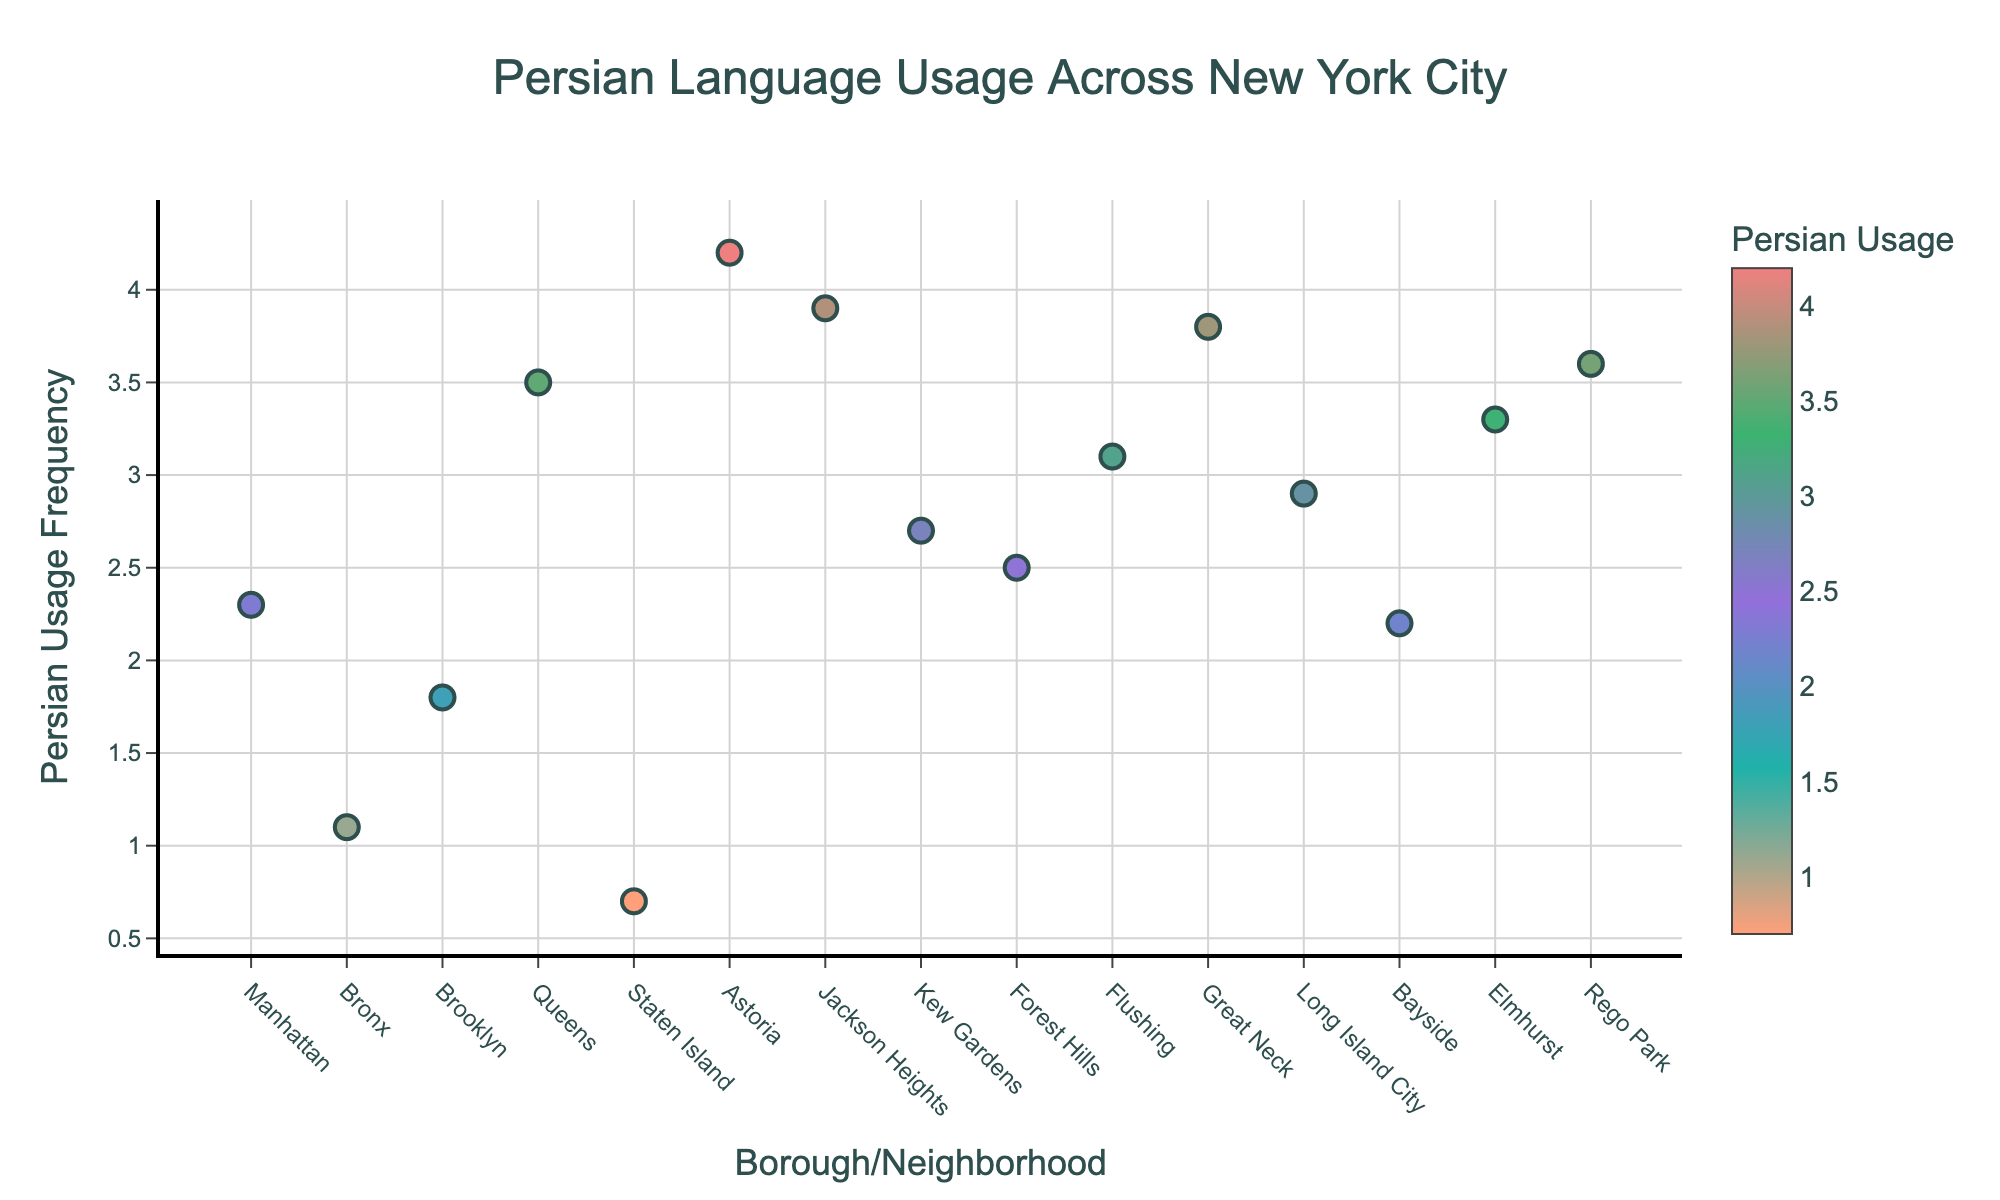What is the title of the plot? The title of a plot is usually found at the top of the visualization. In this case, the title is clearly labeled in the plot.
Answer: Persian Language Usage Across New York City Which borough/neighborhood has the highest Persian language usage frequency? By examining the data points on the plot, the highest value on the y-axis corresponds to the 'Astoria' data point.
Answer: Astoria How many data points are there in total on the plot? Count the number of markers (data points) plotted on the scatter plot. Each marker represents a borough or neighborhood.
Answer: 15 Which borough/neighborhood has the lowest Persian language usage frequency? By examining the data points on the plot, the lowest value on the y-axis corresponds to the 'Staten Island' data point.
Answer: Staten Island What is the Persian language usage frequency in Queens? Find the data point labeled 'Queens' and refer to its value on the y-axis scale.
Answer: 3.5 What is the average Persian language usage frequency among Bronx, Brooklyn, and Queens? Sum the Persian usage frequencies for these boroughs (1.1 + 1.8 + 3.5) and then divide by the number of boroughs (3).
Answer: 2.13 Which borough has a higher Persian usage frequency: Brooklyn or Long Island City? Compare the respective Persian usage frequencies from the plot: Brooklyn is 1.8 and Long Island City is 2.9.
Answer: Long Island City Is the Persian language usage frequency in Elmhurst higher than in Flushing? Compare the Persian usage frequency markers for Elmhurst and Flushing. Elmhurst has a value of 3.3, while Flushing has 3.1.
Answer: Yes Which neighborhoods have a Persian language usage frequency of more than 3? Identify all neighborhoods with y-axis values greater than 3. These values are above 3 and therefore relevant neighborhoods are 'Queens,' 'Astoria,' 'Jackson Heights,' 'Elmhurst,' 'Rego Park,' 'Flushing,' and 'Great Neck.'
Answer: Queens, Astoria, Jackson Heights, Elmhurst, Rego Park, Flushing, Great Neck What is the difference in Persian language usage frequency between Manhattan and Kew Gardens? Subtract the Persian usage frequency of Manhattan from that of Kew Gardens. The value for Kew Gardens is 2.7, and for Manhattan, it is 2.3. So, 2.7 - 2.3.
Answer: 0.4 